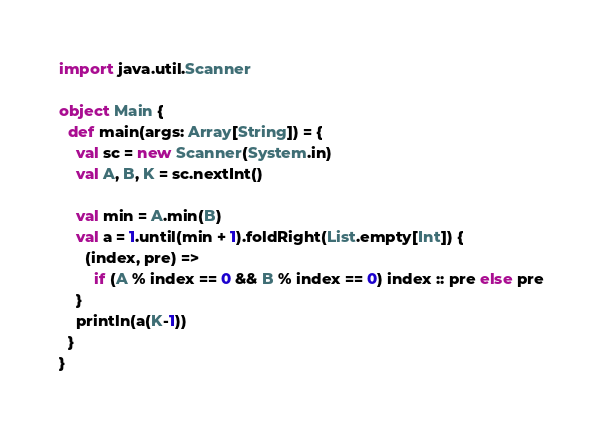<code> <loc_0><loc_0><loc_500><loc_500><_Scala_>import java.util.Scanner

object Main {
  def main(args: Array[String]) = {
    val sc = new Scanner(System.in)
    val A, B, K = sc.nextInt()

    val min = A.min(B)
    val a = 1.until(min + 1).foldRight(List.empty[Int]) {
      (index, pre) =>
        if (A % index == 0 && B % index == 0) index :: pre else pre
    }
    println(a(K-1))
  }
}
</code> 